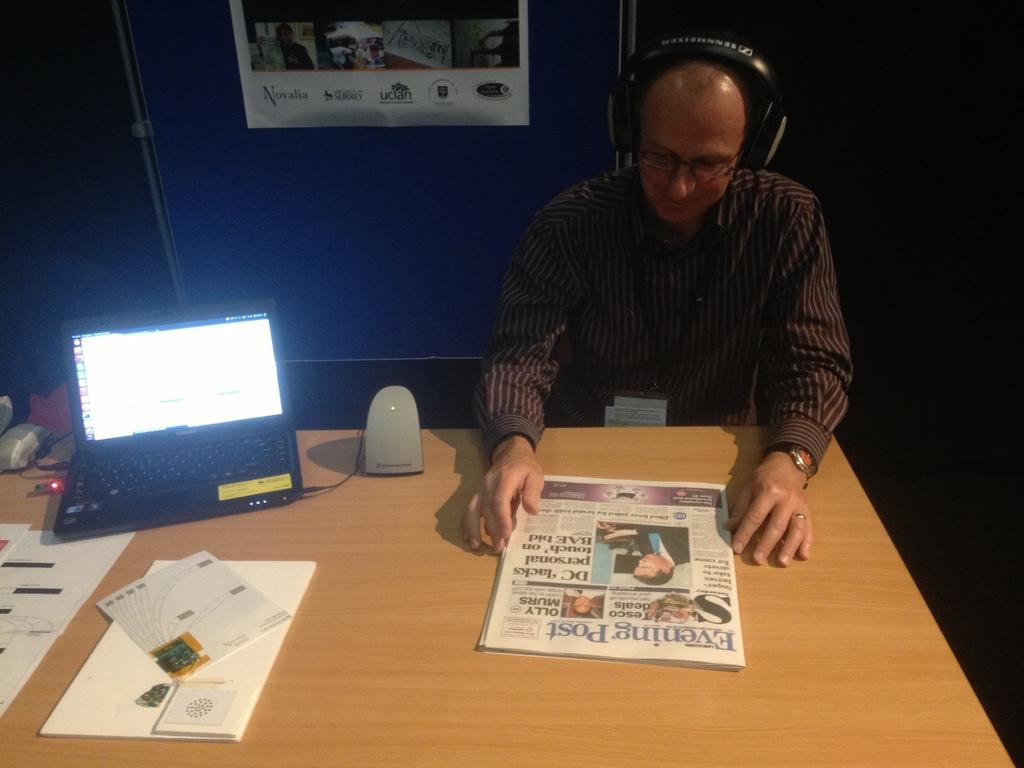<image>
Describe the image concisely. A man sitting at a desk wearing headphones reads the Evening Post. 